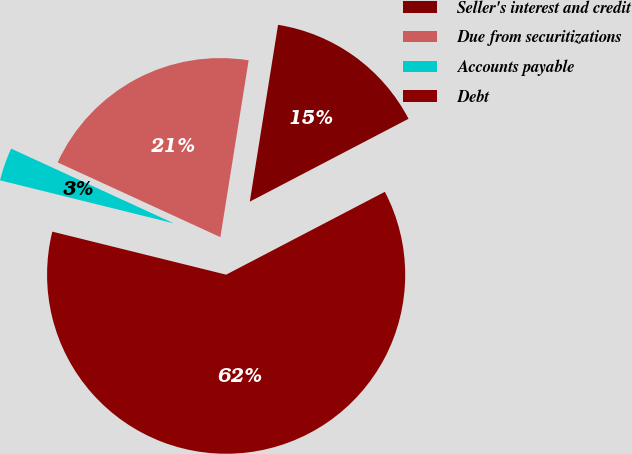<chart> <loc_0><loc_0><loc_500><loc_500><pie_chart><fcel>Seller's interest and credit<fcel>Due from securitizations<fcel>Accounts payable<fcel>Debt<nl><fcel>14.82%<fcel>20.67%<fcel>2.99%<fcel>61.52%<nl></chart> 